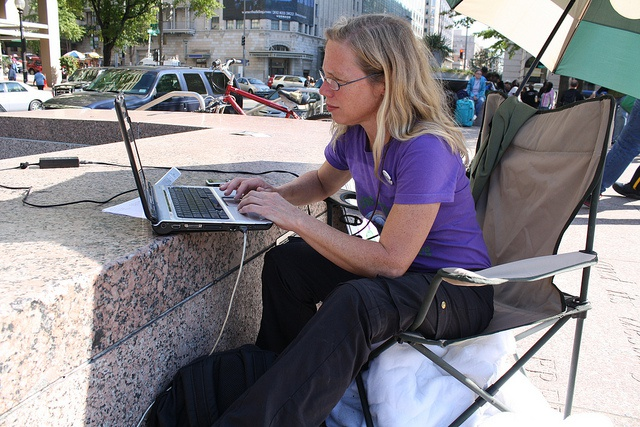Describe the objects in this image and their specific colors. I can see people in maroon, black, gray, and darkgray tones, chair in maroon, gray, black, white, and darkgray tones, umbrella in maroon, ivory, teal, gray, and black tones, car in maroon, black, gray, and darkgray tones, and backpack in maroon, black, and gray tones in this image. 